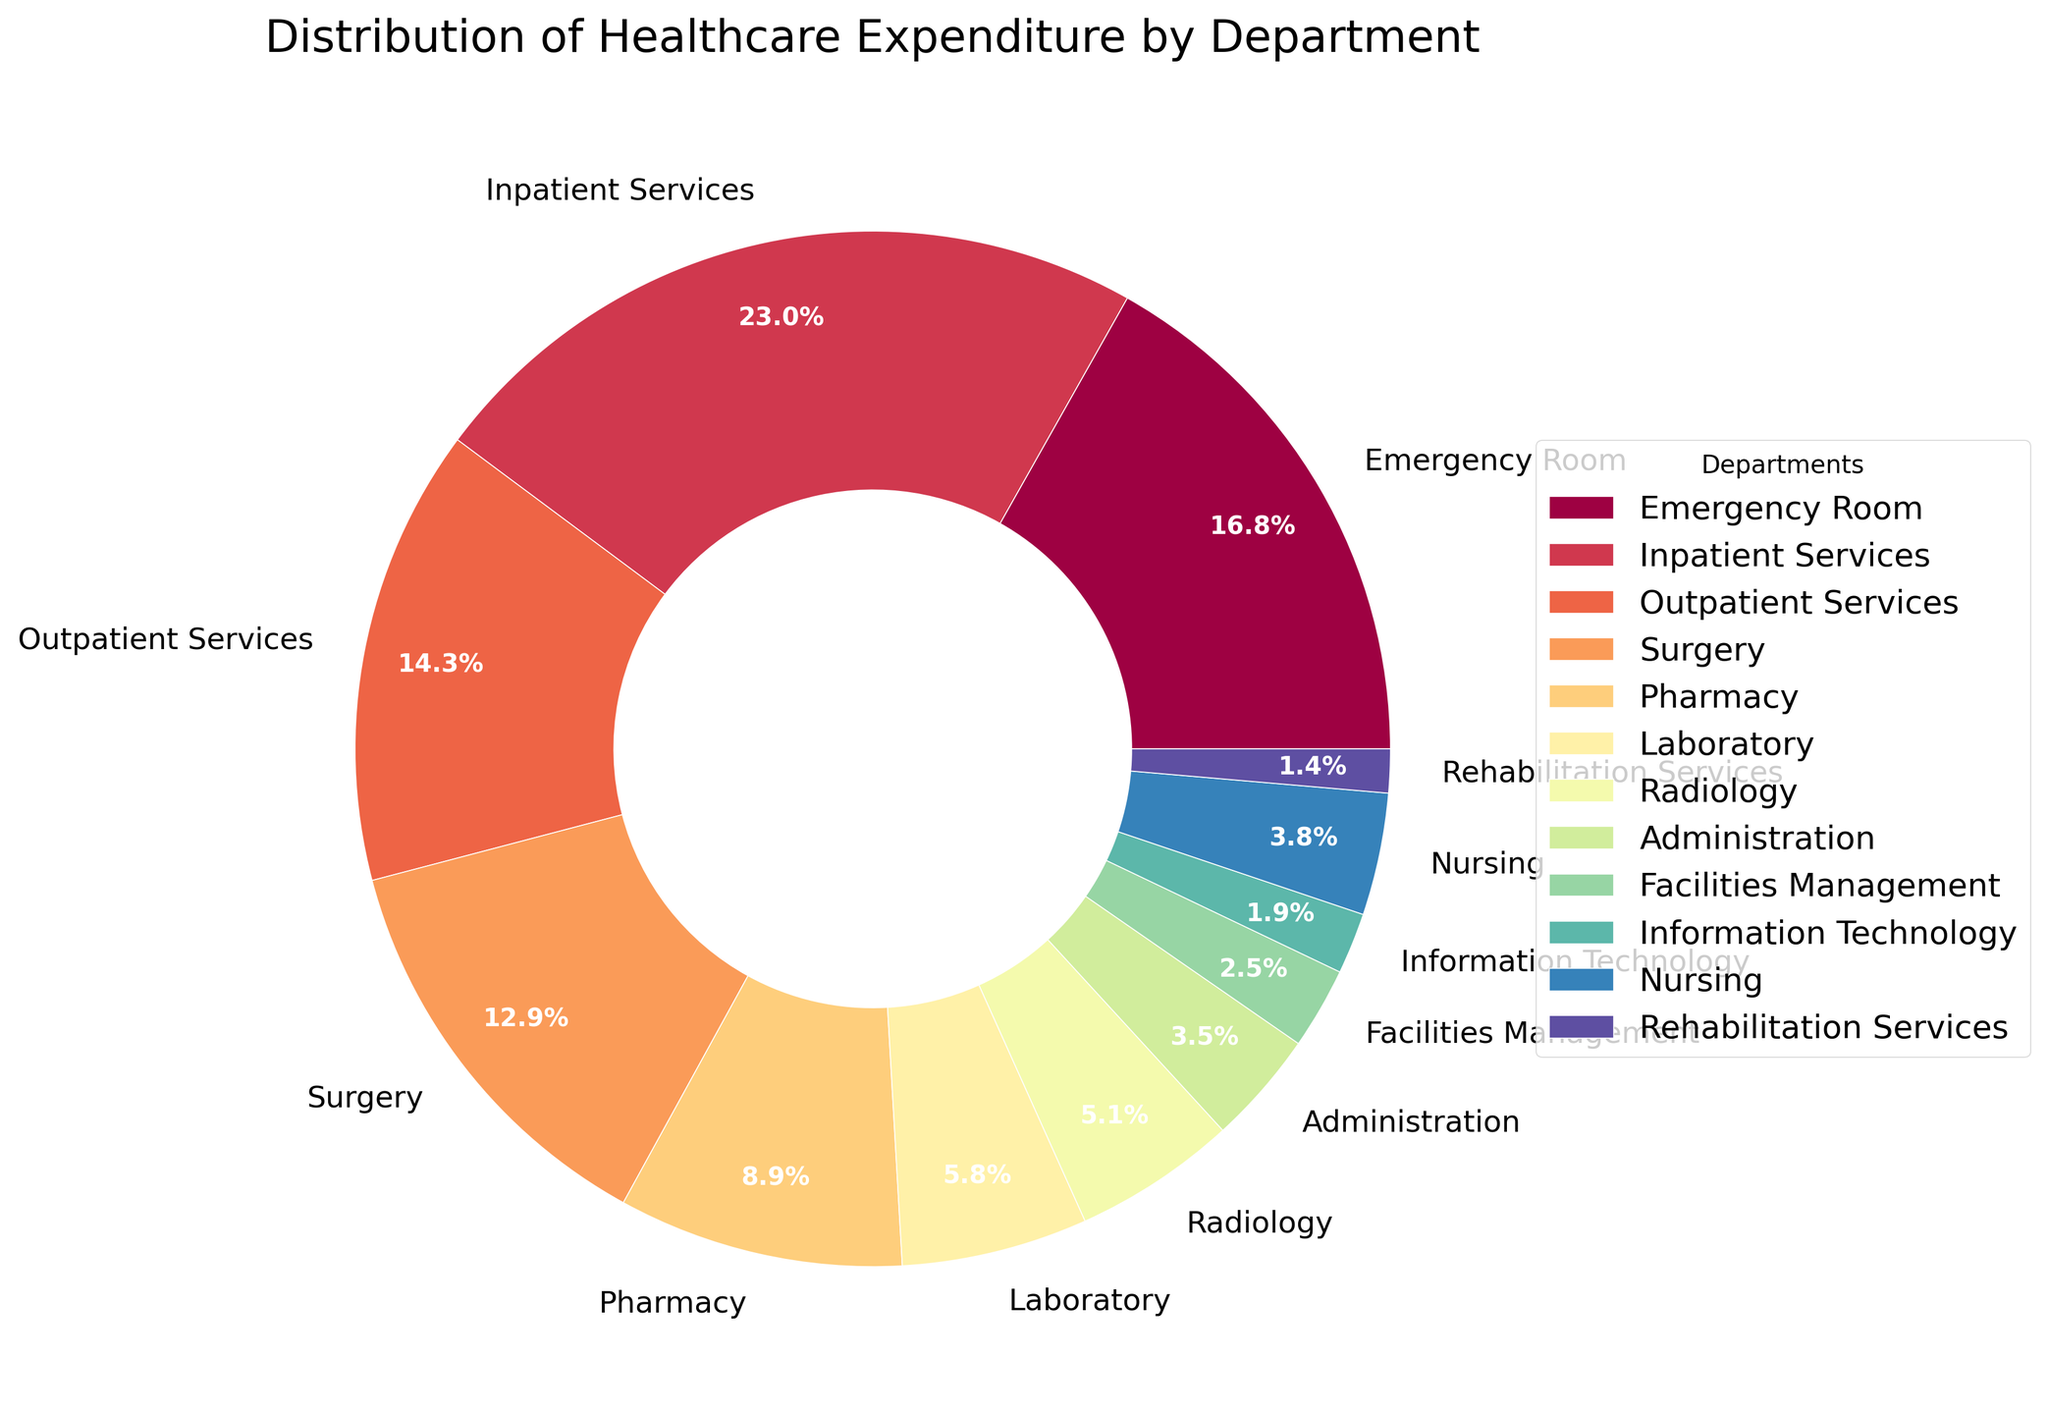Which department has the highest expenditure percentage? By looking at the pie chart, identify the department label with the largest wedge.
Answer: Inpatient Services What is the total expenditure percentage for Surgery and Pharmacy combined? Locate the expenditure percentages for Surgery (14.2%) and Pharmacy (9.8%) on the chart, then sum them up: 14.2% + 9.8% = 24.0%.
Answer: 24.0% Which department has a higher expenditure percentage: Radiology or Laboratory? Compare the two wedges representing Radiology and Laboratory. Radiology is 5.6% and Laboratory is 6.4%, so Laboratory has a higher expenditure percentage.
Answer: Laboratory How much more does the Emergency Room spend compared to Information Technology? Find the expenditure percentages for Emergency Room (18.5%) and Information Technology (2.1%). The difference is 18.5% - 2.1% = 16.4%.
Answer: 16.4% Are there more departments with an expenditure percentage greater than 10% or less than 5%? Count the departments with expenditure percentages greater than 10% (Emergency Room, Inpatient Services, Outpatient Services, and Surgery) and those with less than 5% (Radiology, Administration, Facilities Management, Information Technology, and Rehabilitation Services). There are 4 departments with more than 10% and 5 departments with less than 5%.
Answer: Less than 5% Which three departments combined contribute to less than 10% of the total expenditure? Identify departments with small percentages and sum until reaching close to but less than 10%. Information Technology (2.1%), Rehabilitation Services (1.5%), and Facilities Management (2.8%) sum up to 2.1% + 1.5% + 2.8% = 6.4%. If combined with another department: e.g., Administration (3.9%), the total would exceed 10%. Therefore, three such as Laboratory (6.4%) combined will not fit, etc.
Answer: Information Technology, Rehabilitation Services, Facilities Management What percentage of expenditures is accounted for by departments other than Inpatient Services and Emergency Room? Find the expenditure percentages for Inpatient Services (25.3%) and Emergency Room (18.5%). Subtract their sum from 100%: 100% - (25.3% + 18.5%) = 56.2%.
Answer: 56.2% Considering only Nursing and Rehabilitation Services, what is the average expenditure percentage? Locate the expenditure percentages for Nursing (4.2%) and Rehabilitation Services (1.5%), then calculate their average: (4.2% + 1.5%) / 2 = 2.85%.
Answer: 2.85% 